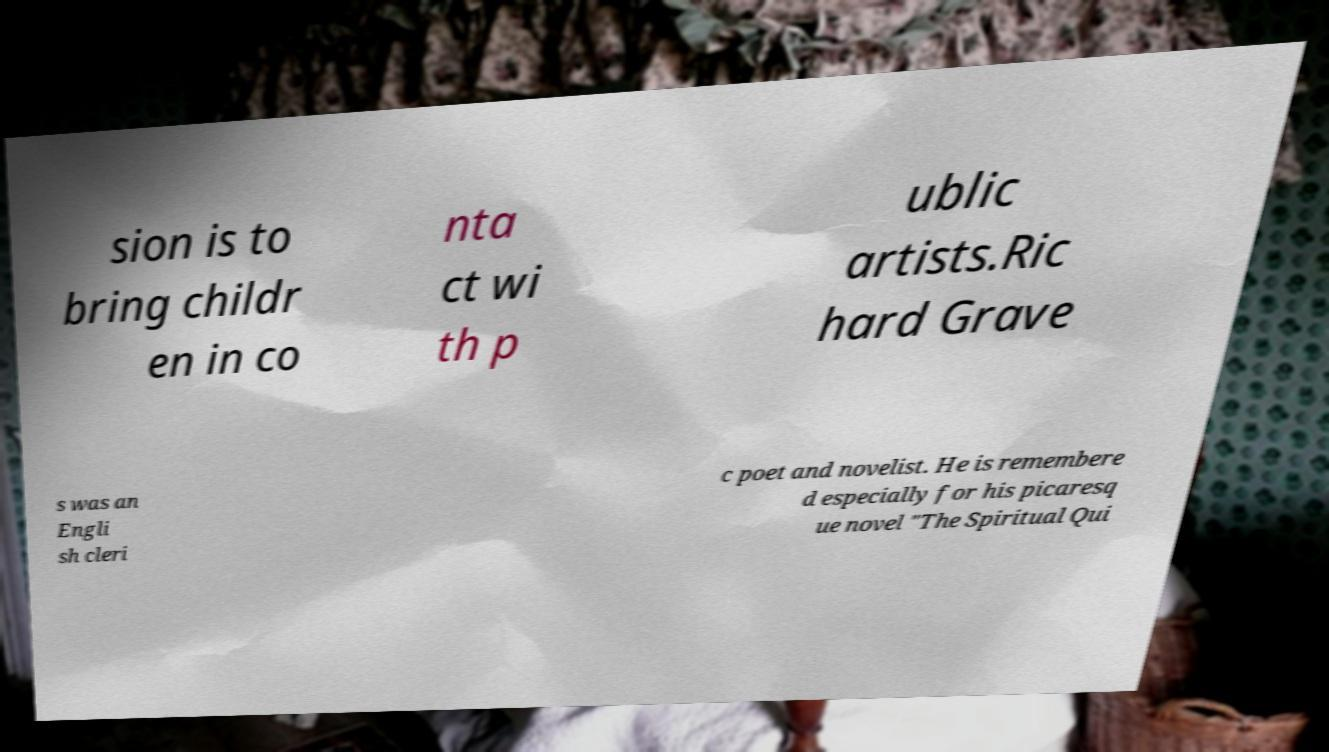What messages or text are displayed in this image? I need them in a readable, typed format. sion is to bring childr en in co nta ct wi th p ublic artists.Ric hard Grave s was an Engli sh cleri c poet and novelist. He is remembere d especially for his picaresq ue novel "The Spiritual Qui 